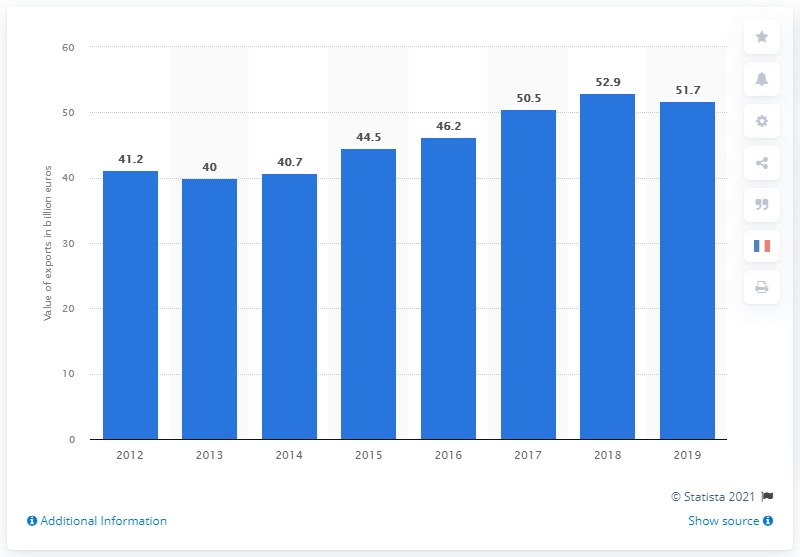Give some essential details in this illustration. The export value of French car manufacturers in 2019 was 51.7 billion euros. 